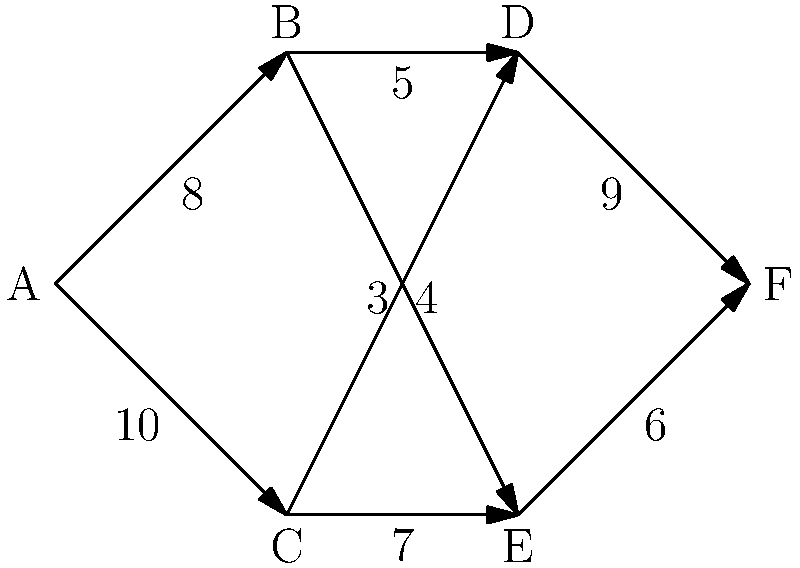As a logistics manager overseeing cargo shipments, you are tasked with determining the maximum flow of goods through a network of distribution centers. The network is represented by the graph above, where each edge is labeled with its capacity (in tons per day). What is the maximum flow of goods that can be shipped from distribution center A to distribution center F? To solve this problem, we'll use the Ford-Fulkerson algorithm to find the maximum flow:

1. Start with zero flow on all edges.

2. Find an augmenting path from A to F:
   Path 1: A → B → D → F (min capacity: 5)
   Increase flow by 5 on this path.

3. Find another augmenting path:
   Path 2: A → C → E → F (min capacity: 6)
   Increase flow by 6 on this path.

4. Find another augmenting path:
   Path 3: A → B → E → F (min capacity: 1)
   Increase flow by 1 on this path.

5. Find another augmenting path:
   Path 4: A → C → D → F (min capacity: 3)
   Increase flow by 3 on this path.

6. No more augmenting paths exist.

7. Calculate total flow:
   $5 + 6 + 1 + 3 = 15$ tons per day

Therefore, the maximum flow from A to F is 15 tons per day.
Answer: 15 tons per day 